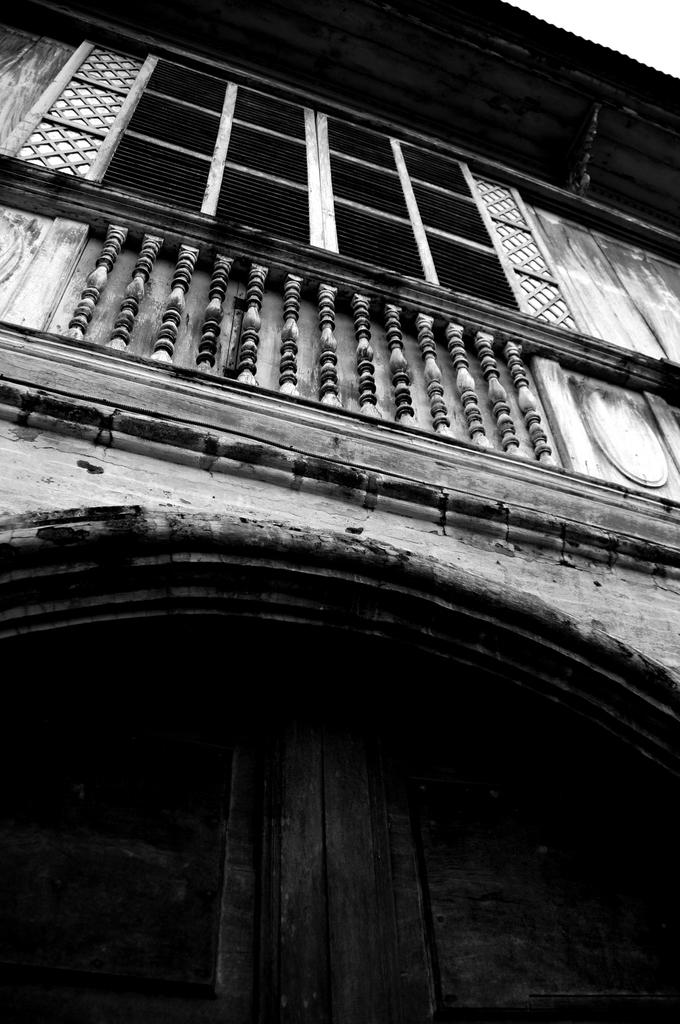What is located at the bottom of the image? There are doors at the bottom of the image. What can be seen in the middle of the image? There is a railing in the middle of the image. What color scheme is used in the image? The image is in black and white color. How many potatoes are visible in the image? There are no potatoes present in the image. What type of grip can be seen on the railing in the image? There is no grip visible on the railing in the image. 